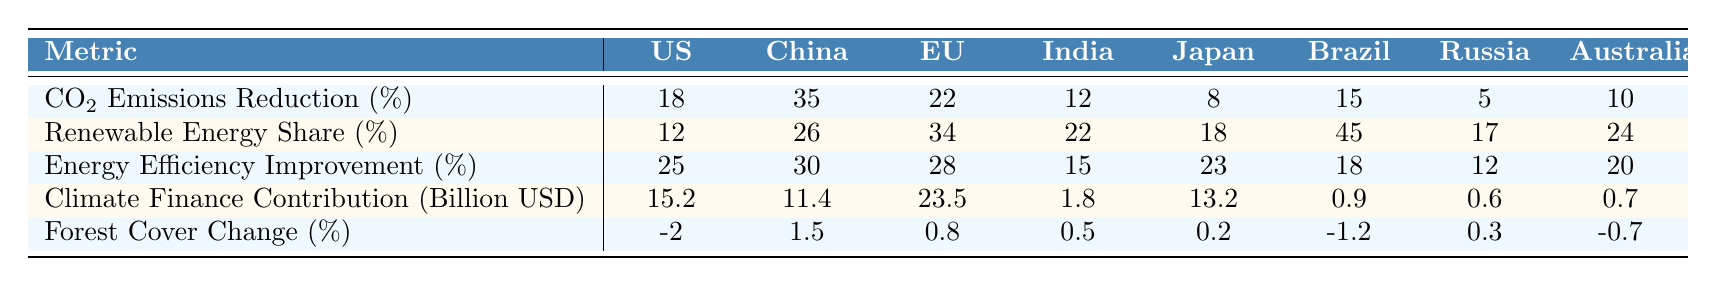What is the CO2 emissions reduction percentage for the European Union? The CO2 emissions reduction percentage for the European Union is listed as 22% in the table.
Answer: 22% Which country has the highest renewable energy share? Brazil has the highest renewable energy share at 45%, as shown in the second row of the table.
Answer: Brazil What is the difference in energy efficiency improvement between the United States and Brazil? The energy efficiency improvement for the United States is 25% while for Brazil it is 12%. The difference is 25% - 12% = 13%.
Answer: 13% Is Japan's climate finance contribution greater than that of Australia? Japan's climate finance contribution is 13.2 billion USD, while Australia's is 0.7 billion USD, indicating that Japan's contribution is significantly greater.
Answer: Yes Calculate the average forest cover change for the listed countries. The forest cover change percentages are -2, 1.5, 0.8, 0.5, 0.2, -1.2, 0.3, -0.7. Summing these gives -1.1, and dividing by 8 (the number of countries) results in an average of -1.1/8 = -0.1375.
Answer: -0.14 (approx) Which country has the second lowest CO2 emissions reduction percentage? The table indicates that Russia has the second lowest CO2 emissions reduction percentage at 5%, following the United States which has 18%.
Answer: Russia If we consider the climate finance contributions of all the countries, what is the total contribution? Adding the climate finance contributions: 15.2 + 11.4 + 23.5 + 1.8 + 13.2 + 0.9 + 0.6 + 0.7 = 77.3 billion USD.
Answer: 77.3 billion USD Among the countries listed, which showed a negative change in forest cover? The countries showing negative change are the United States (-2%) and Brazil (-1.2%). This information can be observed directly from the table.
Answer: United States and Brazil What is the maximum energy efficiency improvement percentage and which country achieved it? The maximum energy efficiency improvement is 25%, achieved by the United States, as indicated in the third row of the table.
Answer: United States Does any country have more than 20% CO2 emissions reduction? Yes, China (35%) and the European Union (22%) both exceed 20% CO2 emissions reduction.
Answer: Yes 